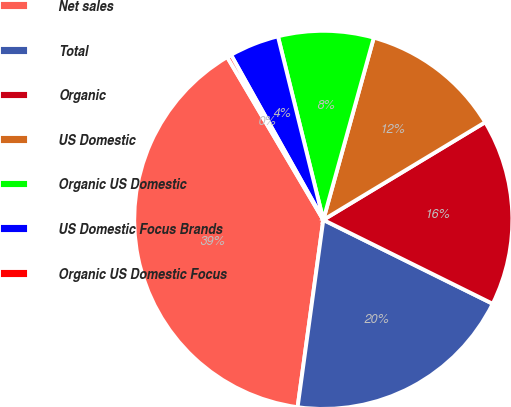Convert chart. <chart><loc_0><loc_0><loc_500><loc_500><pie_chart><fcel>Net sales<fcel>Total<fcel>Organic<fcel>US Domestic<fcel>Organic US Domestic<fcel>US Domestic Focus Brands<fcel>Organic US Domestic Focus<nl><fcel>39.34%<fcel>19.85%<fcel>15.96%<fcel>12.06%<fcel>8.16%<fcel>4.26%<fcel>0.37%<nl></chart> 